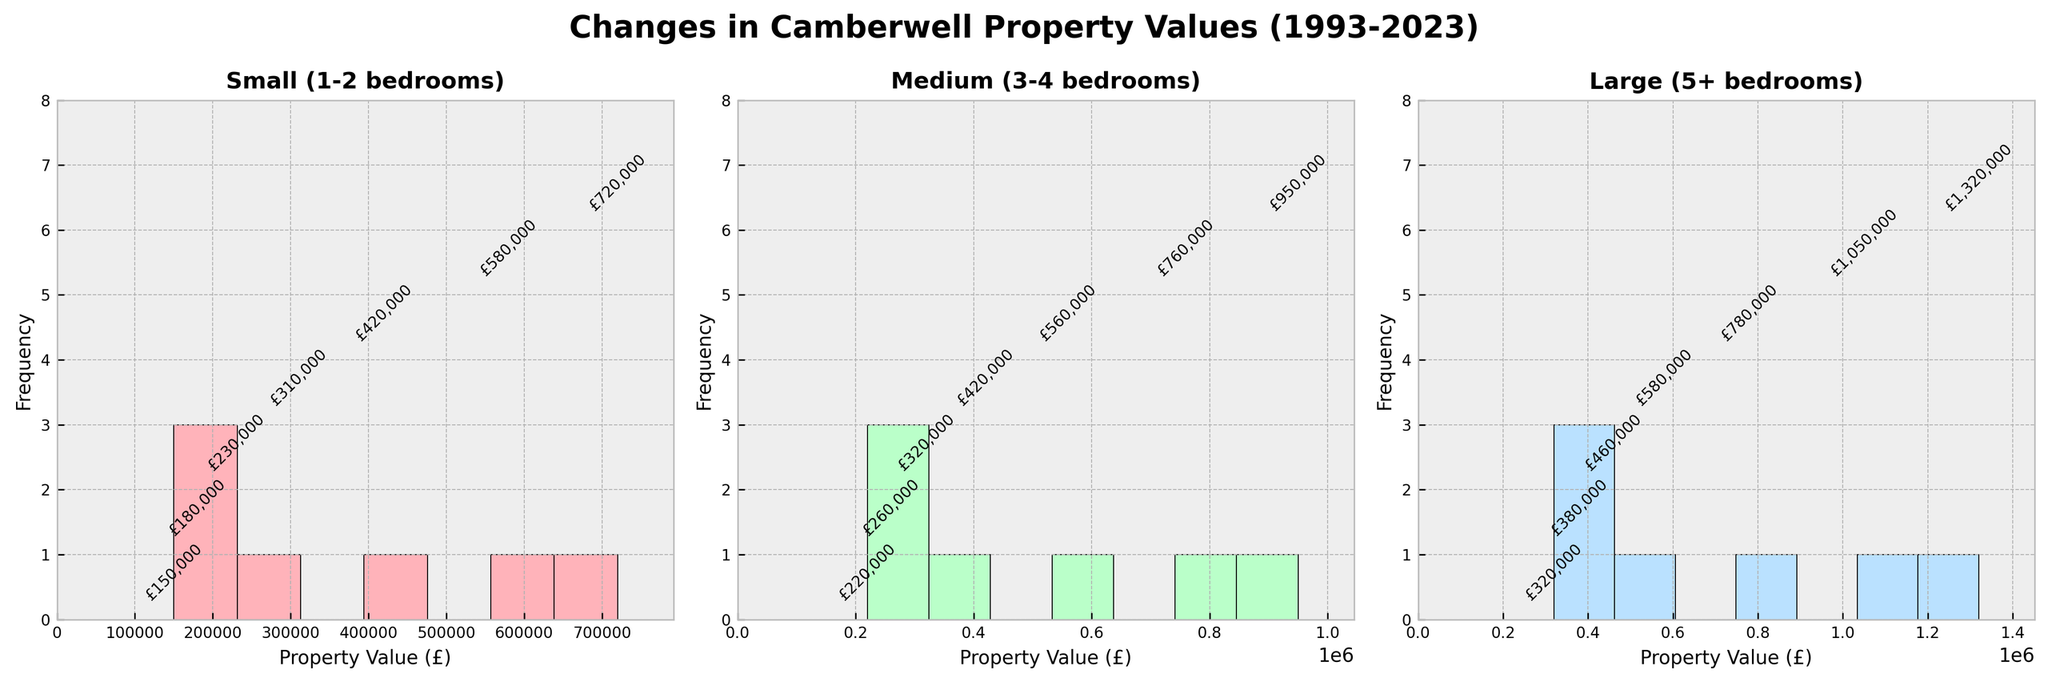What's the title of the figure? The title is centered at the top of the figure, generally larger and bolder than other text. It clearly states the content.
Answer: Changes in Camberwell Property Values (1993-2023) How many subplots are shown in the figure? Subplots are individual plots within a single figure. You can count how many distinct sections are present.
Answer: 3 Which category of property has the highest property value in 2023? Look at the histogram for the year 2023 in each subplot and identify the highest bar.
Answer: Large (5+ bedrooms) What is the range of property values for Small (1-2 bedrooms) properties? The range can be identified from the lowest to the highest values in the histogram for Small properties.
Answer: £150,000 - £720,000 Comparing the median property values in 1998 and 2018, which year has higher values for Medium (3-4 bedrooms) properties? Locate the bins for 1998 and 2018 in the Medium properties subplot, and compare the height of the bars.
Answer: 2018 What is the average property value increase for Large (5+ bedrooms) properties from 1993 to 2023? Calculate the difference between the values in 2023 and 1993, then divide by the number of years.
Answer: £1,000,000 Is the frequency of property values evenly distributed for Small (1-2 bedrooms) properties across the years? Observe the heights of the bars in the Small properties subplot to determine if they are roughly even or not.
Answer: No Which category shows the most significant jump in property values between 2003 and 2008? Compare the height differences between the bars for 2003 and 2008 in all three subplots.
Answer: Large (5+ bedrooms) How did the property values for Medium (3-4 bedrooms) properties change from 2013 to 2023? Look at the bar heights for 2013 and 2023 in the Medium properties subplot to observe the trend.
Answer: Increased Given the trend, which property category is predicted to have the highest value increase if we project it linearly over the next 5 years? Identify the category with the steepest slope of property value increase in the past years.
Answer: Large (5+ bedrooms) 